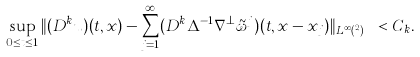Convert formula to latex. <formula><loc_0><loc_0><loc_500><loc_500>\sup _ { 0 \leq t \leq 1 } \| ( D ^ { k } u ) ( t , x ) - \sum _ { j = 1 } ^ { \infty } ( D ^ { k } \Delta ^ { - 1 } \nabla ^ { \perp } \tilde { \omega } ^ { j } ) ( t , x - x _ { j } ) \| _ { L _ { x } ^ { \infty } ( \mathbb { R } ^ { 2 } ) } < C _ { k } .</formula> 